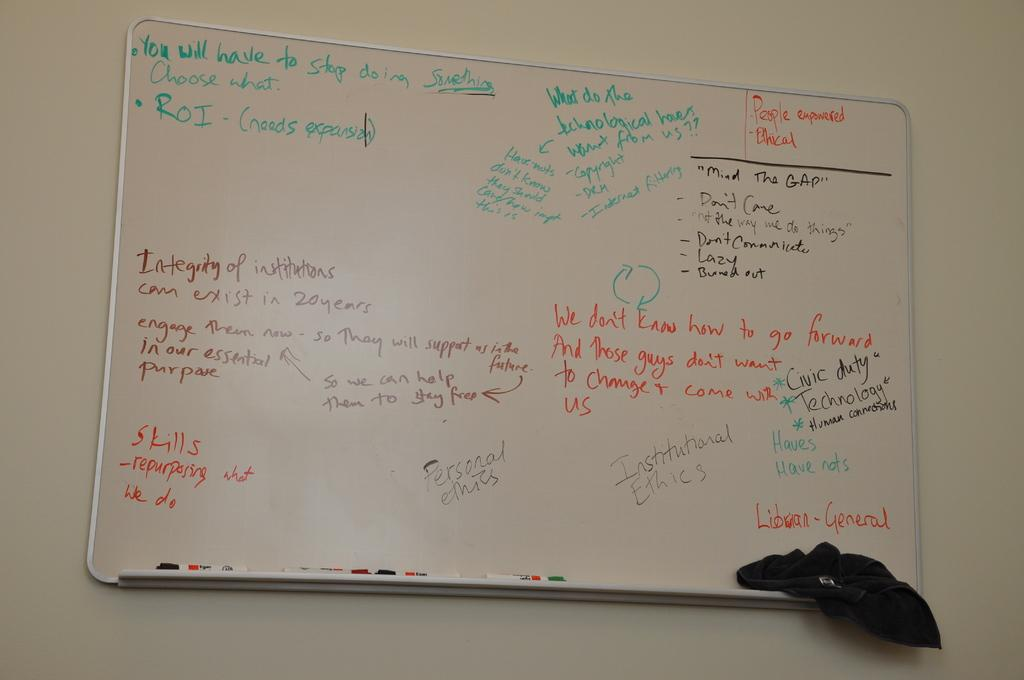<image>
Offer a succinct explanation of the picture presented. A whiteboard has people empowered written in orange at the top right corner. 